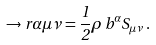Convert formula to latex. <formula><loc_0><loc_0><loc_500><loc_500>\to r { \alpha } { \mu } { \nu } = \frac { 1 } { 2 } \rho \, b ^ { \alpha } S _ { \mu \nu } \, .</formula> 